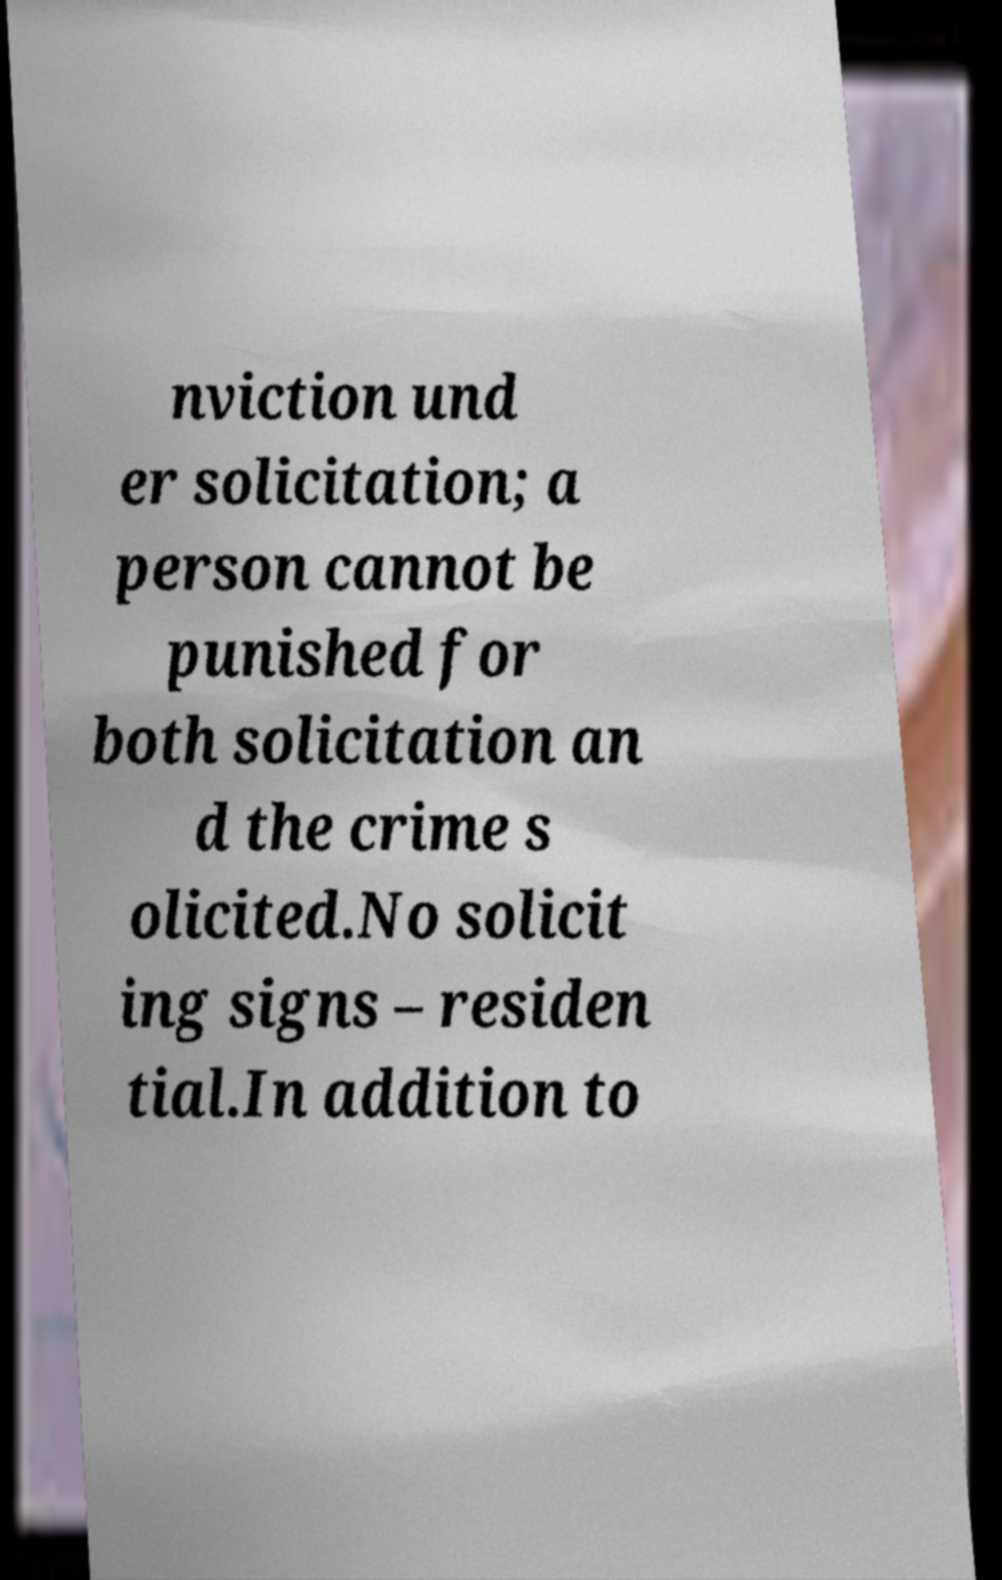Could you assist in decoding the text presented in this image and type it out clearly? nviction und er solicitation; a person cannot be punished for both solicitation an d the crime s olicited.No solicit ing signs – residen tial.In addition to 